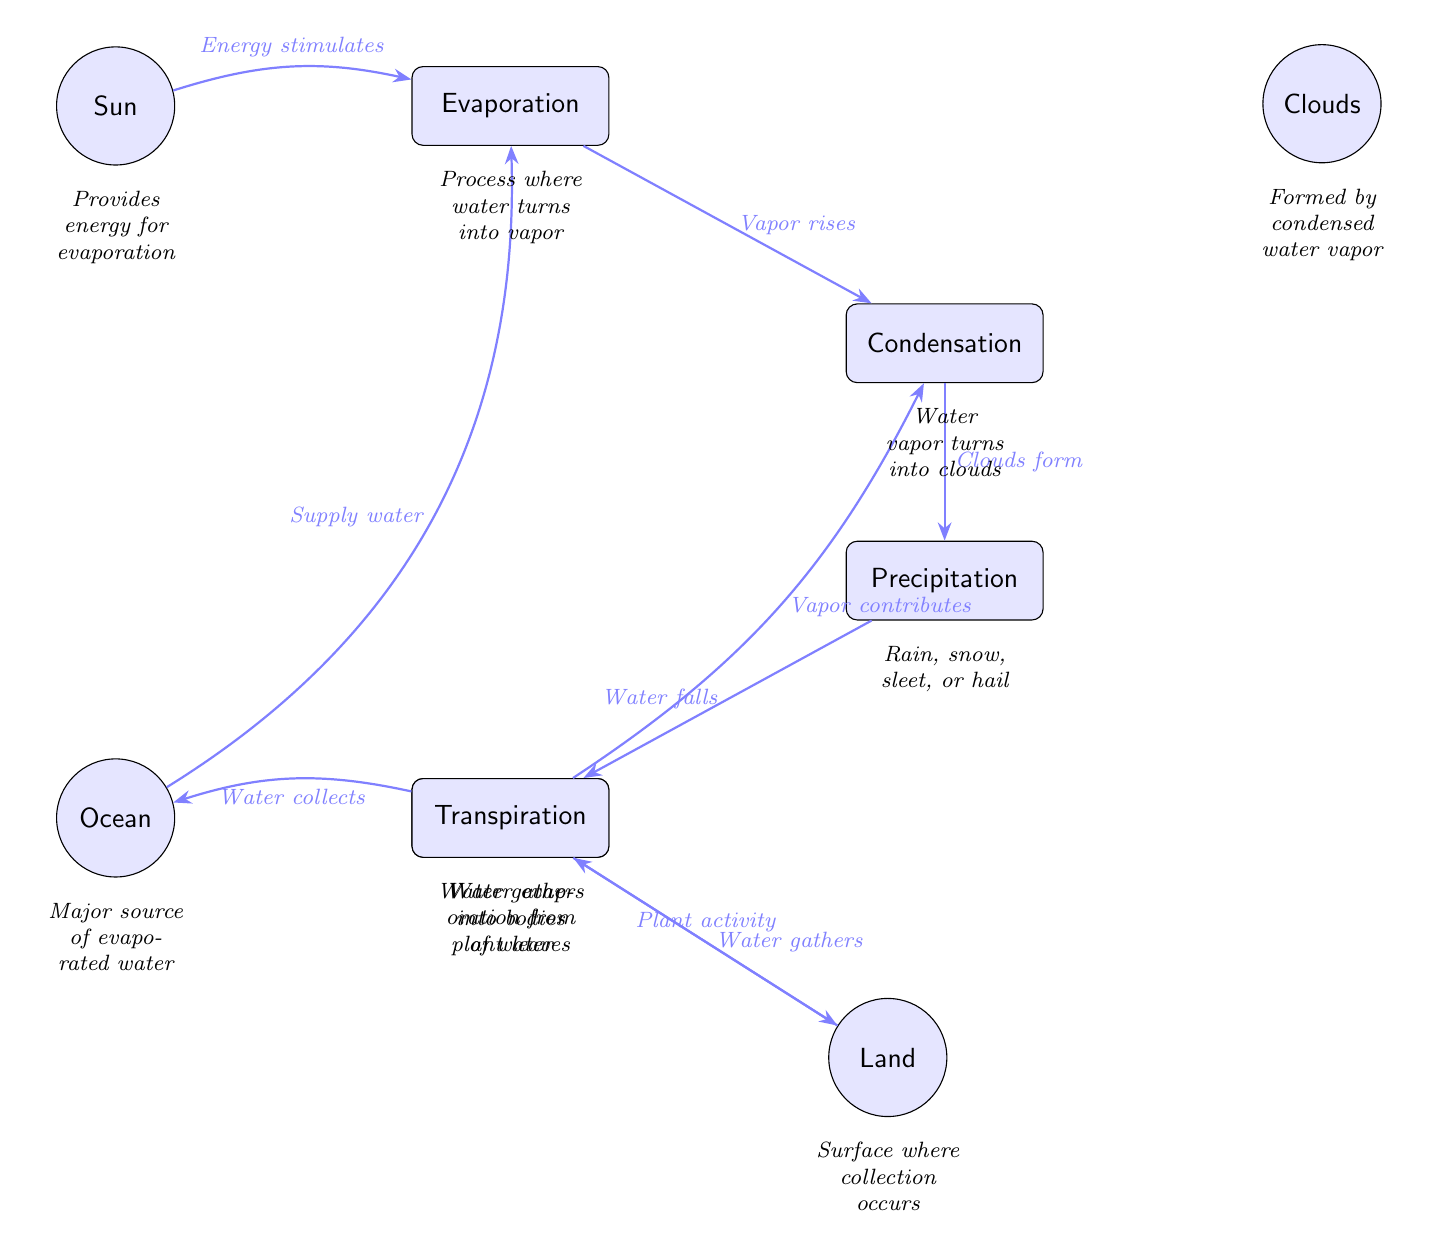What is the main source of energy for the water cycle? The diagram indicates that the "Sun" provides the energy needed for the evaporation process, which is the first step in the water cycle.
Answer: Sun How many processes are shown in the diagram? By counting the nodes labeled as processes, we identify Evaporation, Condensation, Precipitation, Collection, and Transpiration, totaling five processes in the diagram.
Answer: 5 What type of precipitation is illustrated in the diagram? The diagram specifies that the category of precipitation includes "Rain, snow, sleet, or hail," indicating the types of water falling back to the surface from the clouds.
Answer: Rain, snow, sleet, or hail Which process follows condensation? According to the directional arrows in the diagram, the process that immediately follows Condensation is Precipitation, indicating that after clouds form, water falls as precipitation.
Answer: Precipitation From which element does the evaporation process draw water? The diagram connects the element "Ocean" to the Evaporation process via an arrow, indicating that water is evaporated from the ocean, which is identified as a major source of water.
Answer: Ocean How do clouds form in the water cycle? The diagram states that clouds form when water vapor undergoes condensation, which is the transition of water vapor back into liquid droplets that cluster together to create clouds.
Answer: Water vapor turns into clouds What is the relationship between transpiration and condensation? The diagram illustrates that transpiration contributes vapor to the condensation process; thus, the vapor released from plant leaves helps in forming clouds.
Answer: Vapor contributes What happens to precipitation after it occurs? The diagram shows that after precipitation falls, it transitions to the Collection process, where water gathers into bodies of water like oceans and land surfaces.
Answer: Water gathers What is one way land contributes to the water cycle? The diagram illustrates that land contributes through "Plant activity," which is linked to the process of transpiration, showing how plants release water vapor into the atmosphere.
Answer: Plant activity 